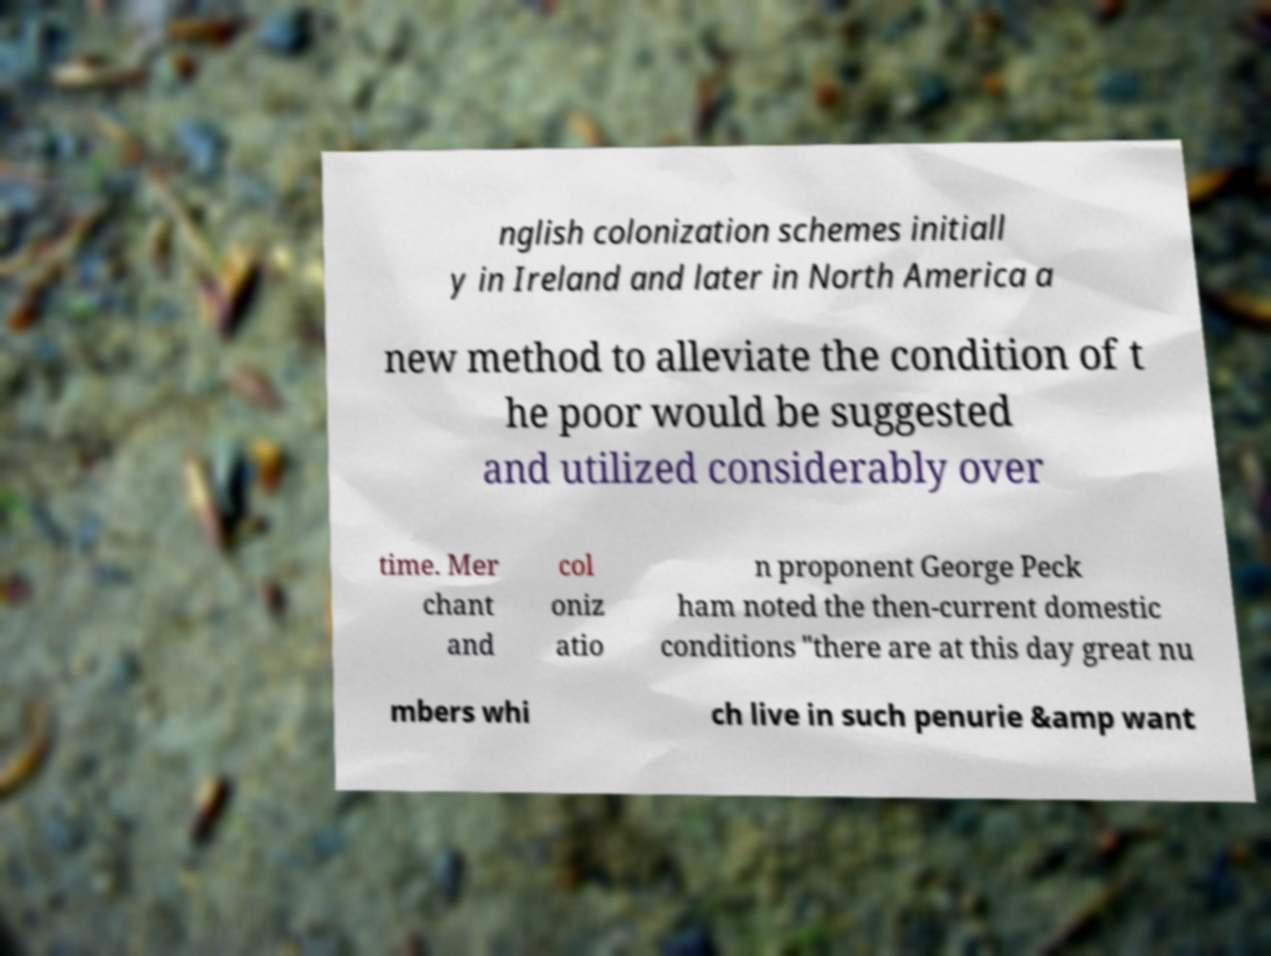I need the written content from this picture converted into text. Can you do that? nglish colonization schemes initiall y in Ireland and later in North America a new method to alleviate the condition of t he poor would be suggested and utilized considerably over time. Mer chant and col oniz atio n proponent George Peck ham noted the then-current domestic conditions "there are at this day great nu mbers whi ch live in such penurie &amp want 